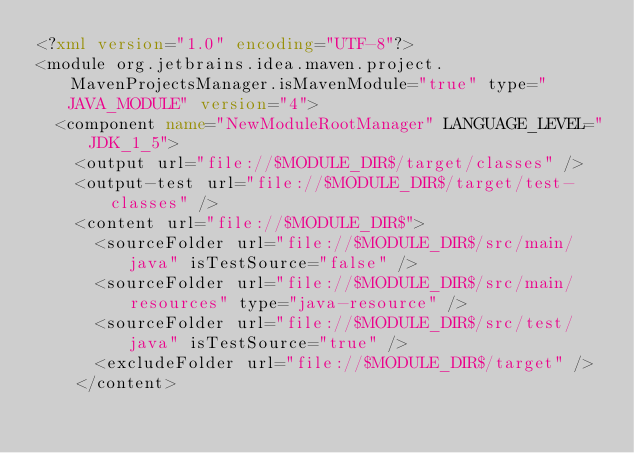Convert code to text. <code><loc_0><loc_0><loc_500><loc_500><_XML_><?xml version="1.0" encoding="UTF-8"?>
<module org.jetbrains.idea.maven.project.MavenProjectsManager.isMavenModule="true" type="JAVA_MODULE" version="4">
  <component name="NewModuleRootManager" LANGUAGE_LEVEL="JDK_1_5">
    <output url="file://$MODULE_DIR$/target/classes" />
    <output-test url="file://$MODULE_DIR$/target/test-classes" />
    <content url="file://$MODULE_DIR$">
      <sourceFolder url="file://$MODULE_DIR$/src/main/java" isTestSource="false" />
      <sourceFolder url="file://$MODULE_DIR$/src/main/resources" type="java-resource" />
      <sourceFolder url="file://$MODULE_DIR$/src/test/java" isTestSource="true" />
      <excludeFolder url="file://$MODULE_DIR$/target" />
    </content></code> 